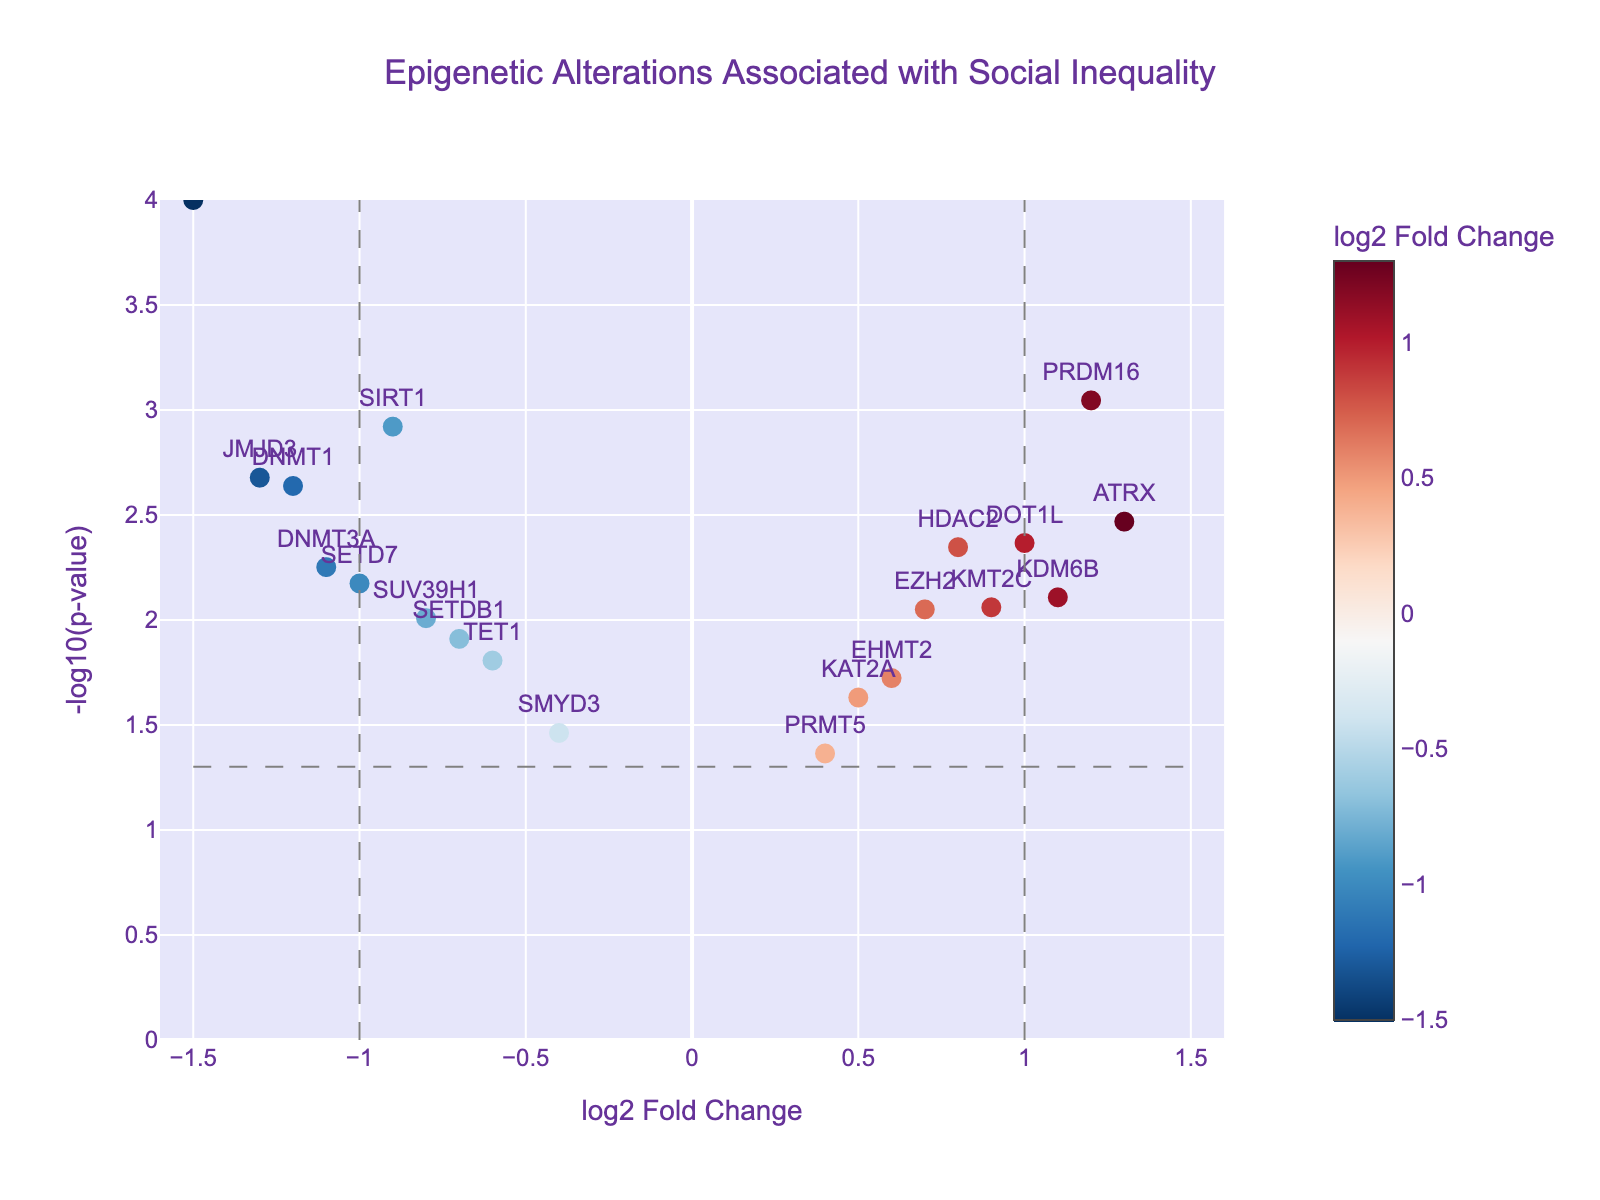What is the title of the plot? The title is typically found at the top of the plot. In this figure, it's "Epigenetic Alterations Associated with Social Inequality".
Answer: Epigenetic Alterations Associated with Social Inequality How many genes have a log2 fold change greater than 1? To find the number of genes with a log2 fold change > 1, look at the genes located to the right of the vertical line at 1.
Answer: Three genes Which gene has the lowest p-value? The p-value is indicated on the y-axis as -log10(p-value). The highest positioned gene on the y-axis will have the lowest p-value. “MECP2” is at the highest point with the most significant p-value.
Answer: MECP2 Are there any genes with both positive log2 fold change and a p-value less than 0.01? To answer this, look for genes situated right of zero on the x-axis (positive log2 fold change) and above the horizontal dashed line (indicating p-value < 0.01, which is -log10(0.01)).
Answer: HDAC2, ATRX, PRDM16, DOT1L How many genes fall within the region indicating non-significant changes (log2 fold change between -1 and 1 and p-value > 0.05)? This region is between -1 and 1 on the x-axis and below the horizontal cutoff on the y-axis. Count the number of genes falling in these boundaries.
Answer: Three genes Which gene has the highest log2 fold change? To determine this, identify the gene located furthest to the right on the x-axis.
Answer: ATRX Compare the log2 fold changes of DNMT1 and DNMT3A. Which is more negative? DNMT1 and DNMT3A both have negative log2 fold changes, but comparing their positions on the x-axis, DNMT1 (-1.2) is more negative than DNMT3A (-1.1).
Answer: DNMT1 What is the log2 fold change and p-value of the "KAT2A" gene? Look at the hover information provided for "KAT2A" to get the specific values.
Answer: 0.5, 0.0234 Which gene appears closest to the vertical line at log2 fold change of 0? Find the gene nearest to the center of the x-axis at log2 fold change = 0.
Answer: PRMT5 Identify the genes with a log2 fold change between -1 and 1 and a p-value less than 0.01. Genes that lie between the -1 and 1 boundaries on the x-axis and above the p-value cutoff line in the center are in this range.
Answer: HDAC2, TET1, DOT1L, SETDB1, EZH2 